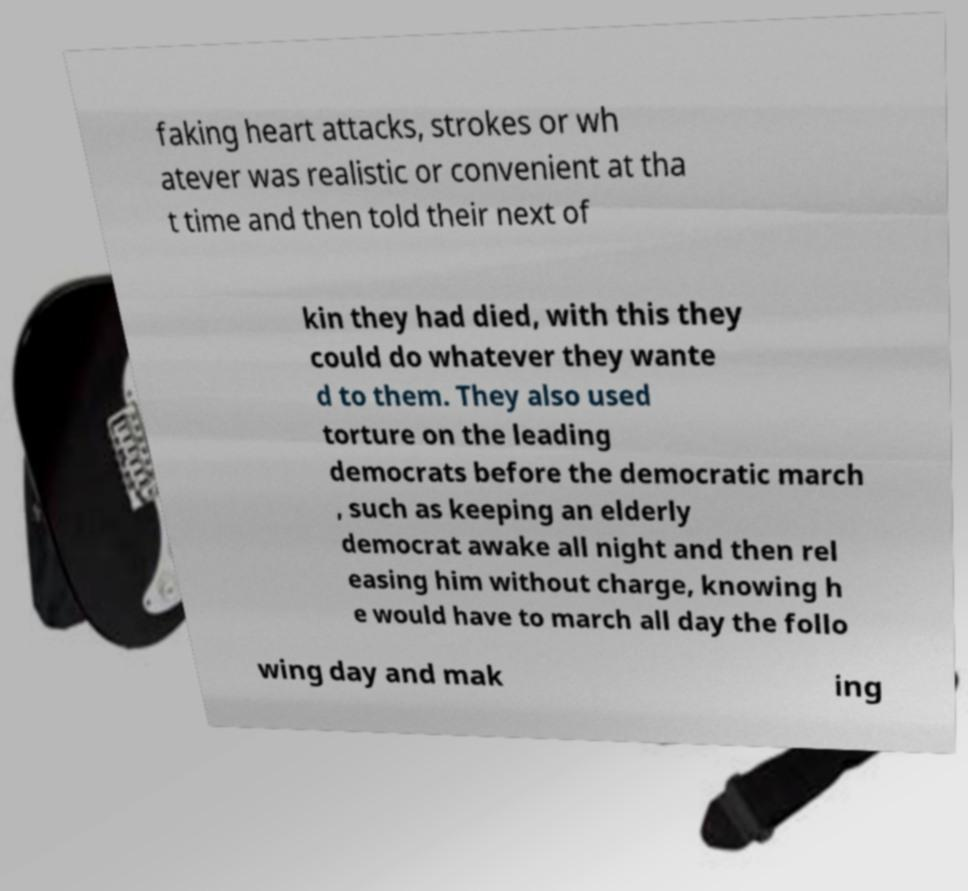For documentation purposes, I need the text within this image transcribed. Could you provide that? faking heart attacks, strokes or wh atever was realistic or convenient at tha t time and then told their next of kin they had died, with this they could do whatever they wante d to them. They also used torture on the leading democrats before the democratic march , such as keeping an elderly democrat awake all night and then rel easing him without charge, knowing h e would have to march all day the follo wing day and mak ing 